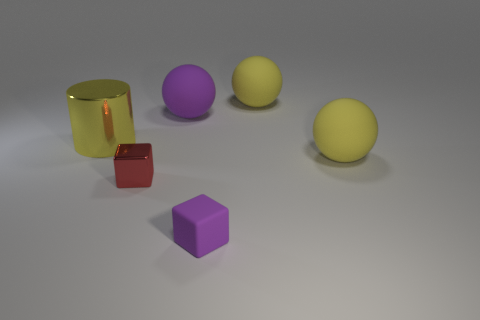Add 2 yellow matte objects. How many objects exist? 8 Subtract all purple spheres. How many spheres are left? 2 Subtract all large yellow balls. How many balls are left? 1 Subtract all blocks. How many objects are left? 4 Subtract 3 balls. How many balls are left? 0 Subtract all brown cylinders. Subtract all red blocks. How many cylinders are left? 1 Subtract all blue cubes. How many red balls are left? 0 Subtract all purple matte blocks. Subtract all big purple rubber objects. How many objects are left? 4 Add 6 small matte cubes. How many small matte cubes are left? 7 Add 3 large yellow shiny things. How many large yellow shiny things exist? 4 